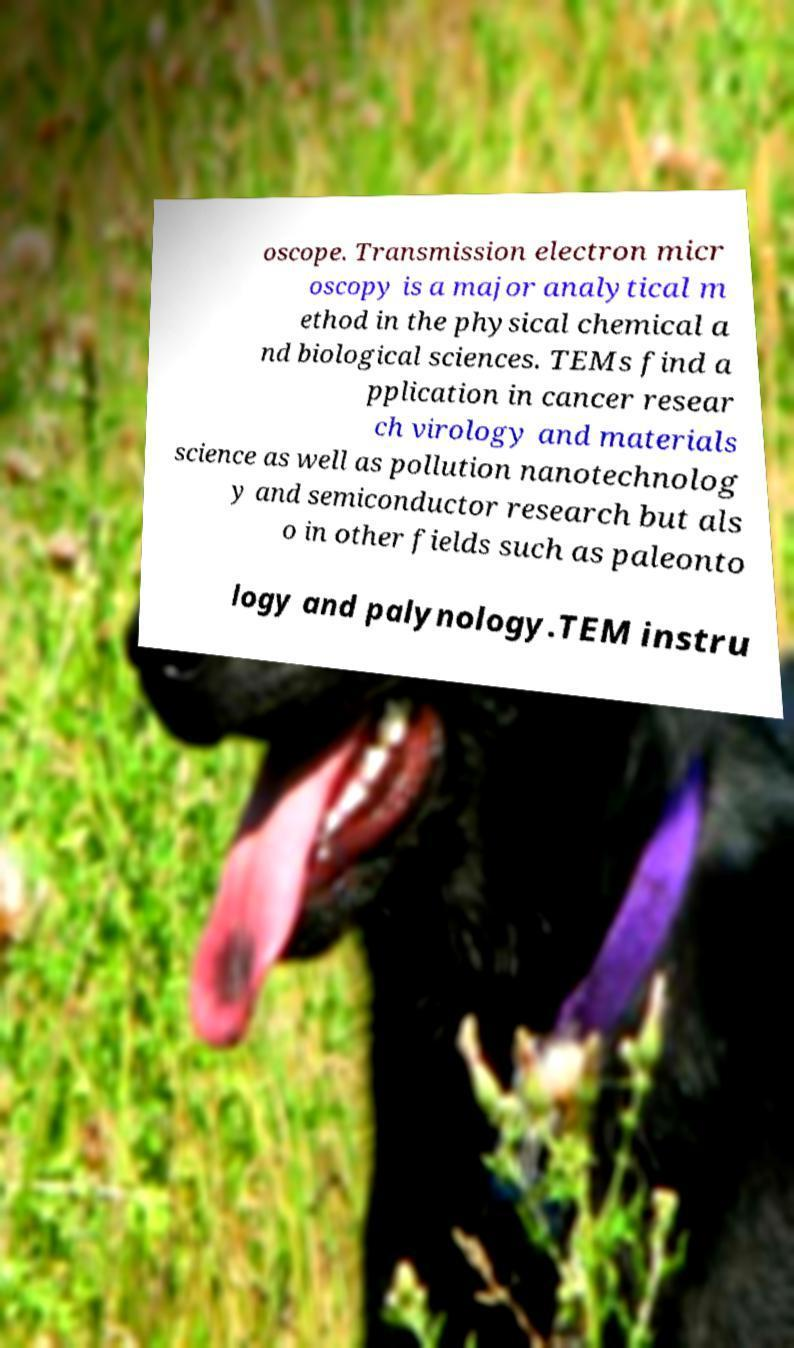Can you read and provide the text displayed in the image?This photo seems to have some interesting text. Can you extract and type it out for me? oscope. Transmission electron micr oscopy is a major analytical m ethod in the physical chemical a nd biological sciences. TEMs find a pplication in cancer resear ch virology and materials science as well as pollution nanotechnolog y and semiconductor research but als o in other fields such as paleonto logy and palynology.TEM instru 